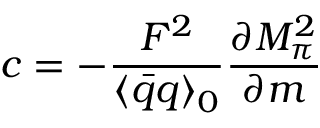<formula> <loc_0><loc_0><loc_500><loc_500>c = - \frac { F ^ { 2 } } { \langle \bar { q } q \rangle _ { 0 } } \frac { \partial M _ { \pi } ^ { 2 } } { \partial m }</formula> 